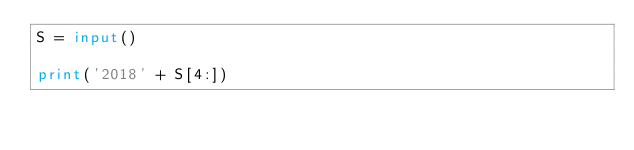<code> <loc_0><loc_0><loc_500><loc_500><_Python_>S = input()

print('2018' + S[4:])</code> 